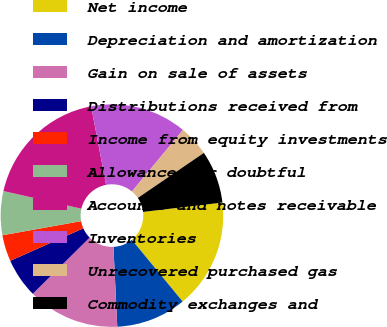Convert chart. <chart><loc_0><loc_0><loc_500><loc_500><pie_chart><fcel>Net income<fcel>Depreciation and amortization<fcel>Gain on sale of assets<fcel>Distributions received from<fcel>Income from equity investments<fcel>Allowance for doubtful<fcel>Accounts and notes receivable<fcel>Inventories<fcel>Unrecovered purchased gas<fcel>Commodity exchanges and<nl><fcel>15.92%<fcel>10.19%<fcel>13.37%<fcel>5.74%<fcel>3.83%<fcel>6.37%<fcel>18.47%<fcel>14.01%<fcel>4.46%<fcel>7.65%<nl></chart> 